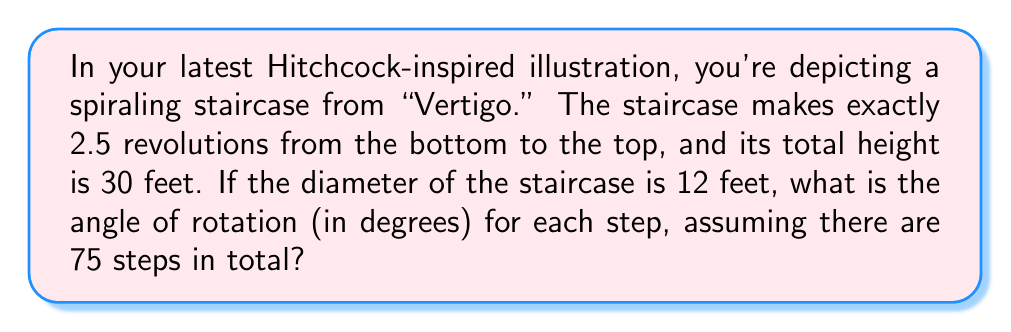Teach me how to tackle this problem. Let's approach this step-by-step:

1) First, we need to calculate the total angle of rotation for the entire staircase:
   2.5 revolutions = 2.5 × 360° = 900°

2) Now, we need to find the angle for each step:
   $\text{Angle per step} = \frac{\text{Total angle}}{\text{Number of steps}} = \frac{900°}{75}$

3) To calculate this, we perform the division:
   $\frac{900}{75} = 12$

4) Therefore, each step rotates 12° around the central axis of the staircase.

5) We can verify this by calculating the pitch of the helix:

   The pitch (vertical distance traveled in one complete revolution) is:
   $\text{Pitch} = \frac{\text{Total height}}{\text{Number of revolutions}} = \frac{30 \text{ ft}}{2.5} = 12 \text{ ft}$

   The length of the helical path can be calculated using:
   $$L = \sqrt{(2\pi r)^2 + p^2}$$
   where $r$ is the radius and $p$ is the pitch.

   $r = 6 \text{ ft}$ (half the diameter)
   
   $$L = \sqrt{(2\pi \cdot 6)^2 + 12^2} \approx 38.32 \text{ ft}$$

   The arc length per step is:
   $\frac{38.32 \text{ ft}}{75 \text{ steps}} \approx 0.51 \text{ ft}$

   This confirms our calculation, as a 12° rotation on a circle with 6 ft radius would create an arc of approximately 0.51 ft.

[asy]
import geometry;

size(200);
real r = 3;
real h = 5;
int steps = 15;

path helix = (r,0,0);
for (int i=1; i <= steps; ++i) {
  real t = 2pi*i/steps;
  helix = helix--(r*cos(t), r*sin(t), h*i/steps);
}

draw(helix, blue+linewidth(1.5));
draw(circle(O, r), dashed);
draw((0,0,0)--(0,0,h), Arrow3);
label("Height", (0,0,h/2), E);

camera.upright = true;
camera.phi = 60;
camera.theta = 45;
</asy]
Answer: The angle of rotation for each step is 12°. 